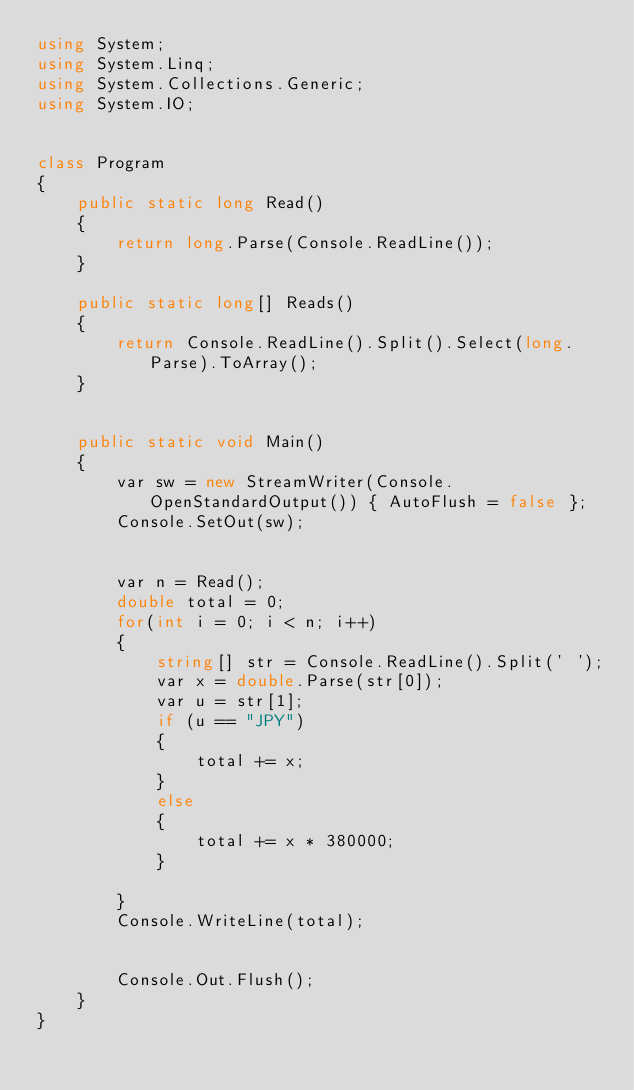Convert code to text. <code><loc_0><loc_0><loc_500><loc_500><_C#_>using System;
using System.Linq;
using System.Collections.Generic;
using System.IO;


class Program
{
    public static long Read()
    {
        return long.Parse(Console.ReadLine());
    }

    public static long[] Reads()
    {
        return Console.ReadLine().Split().Select(long.Parse).ToArray();
    }


    public static void Main()
    {
        var sw = new StreamWriter(Console.OpenStandardOutput()) { AutoFlush = false };
        Console.SetOut(sw);


        var n = Read();
        double total = 0;
        for(int i = 0; i < n; i++)
        {
            string[] str = Console.ReadLine().Split(' ');
            var x = double.Parse(str[0]);
            var u = str[1];
            if (u == "JPY")
            {
                total += x;
            }
            else
            {
                total += x * 380000;
            }

        }
        Console.WriteLine(total);


        Console.Out.Flush();
    }
}</code> 